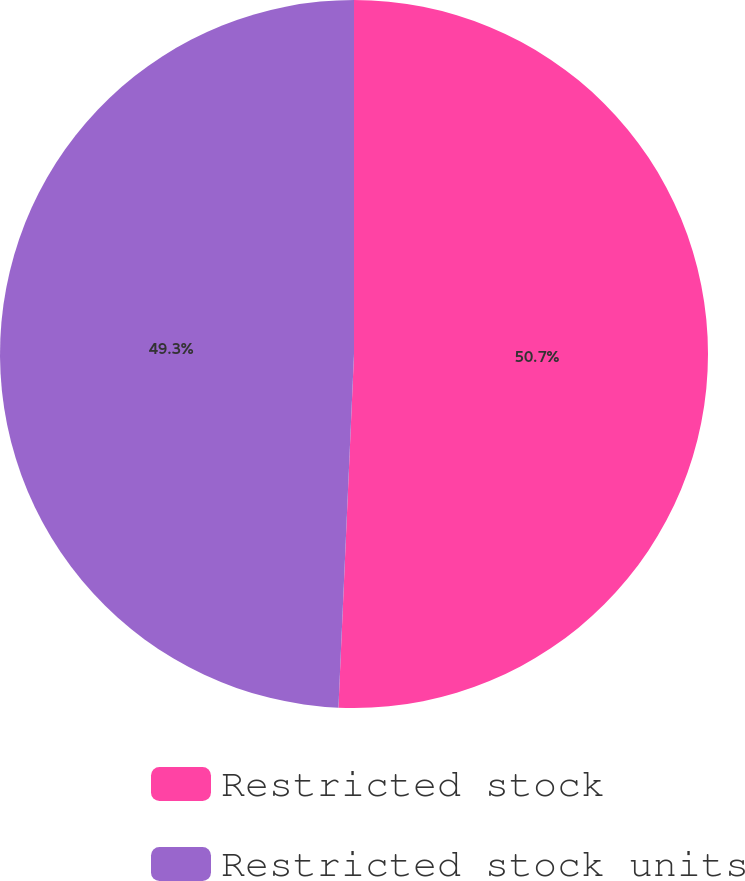Convert chart. <chart><loc_0><loc_0><loc_500><loc_500><pie_chart><fcel>Restricted stock<fcel>Restricted stock units<nl><fcel>50.7%<fcel>49.3%<nl></chart> 